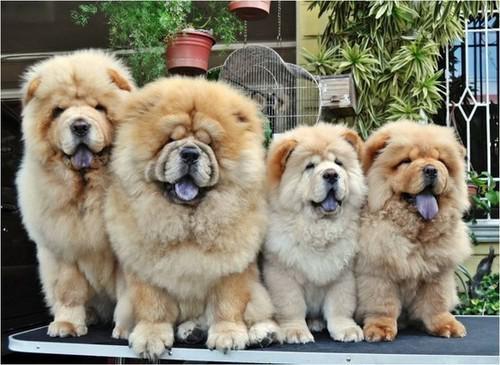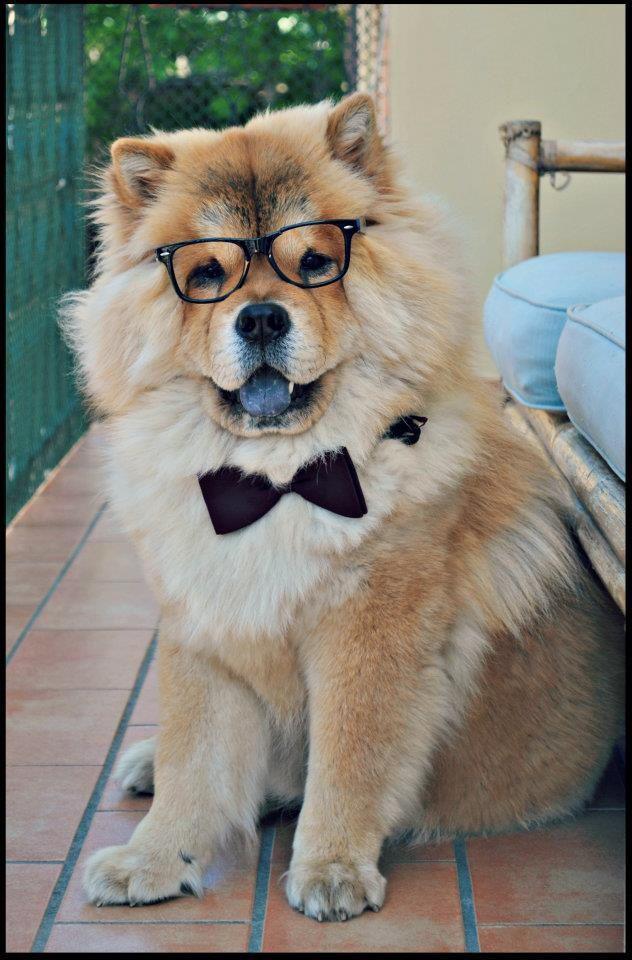The first image is the image on the left, the second image is the image on the right. For the images shown, is this caption "One of the images contains at least four dogs." true? Answer yes or no. Yes. 